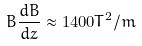<formula> <loc_0><loc_0><loc_500><loc_500>B \frac { d B } { d z } \approx 1 4 0 0 T ^ { 2 } / m</formula> 